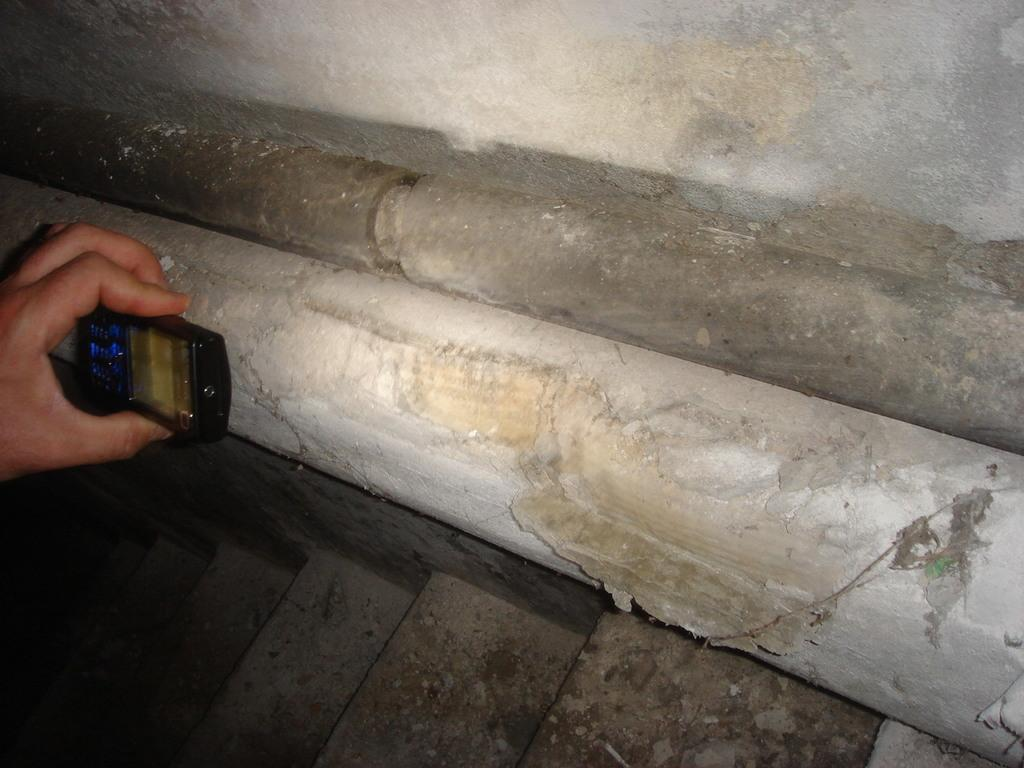What is being held by the hand in the image? There is a person's hand holding a mobile in the image. On which side of the image is the hand located? The hand is on the left side of the image. What architectural feature can be seen at the bottom of the image? There are stairs at the bottom of the image. What is beside the stairs in the image? There is a wall beside the stairs in the image. What type of insurance policy is being discussed in the image? There is no discussion of insurance in the image; it features a person's hand holding a mobile and a wall beside stairs. 